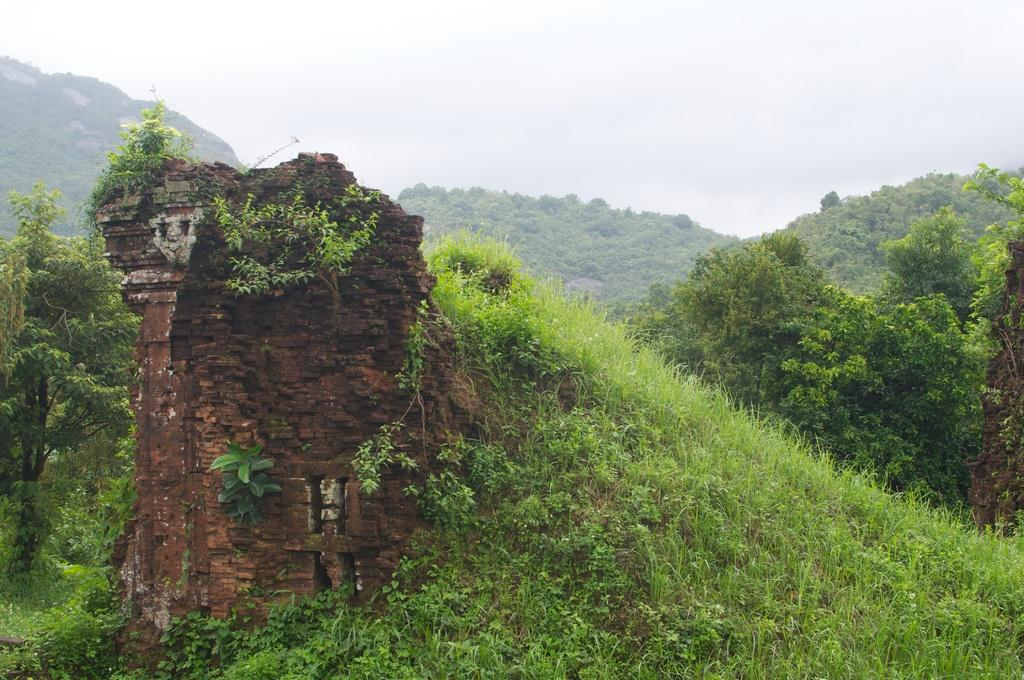What type of vegetation can be seen in the image? There are trees and grass in the image. What type of terrain is visible in the image? There are hills in the image. What is visible in the background of the image? The sky is visible in the image. What can be seen in the sky in the image? Clouds are present in the sky. What type of drink is being served in the image? There is no drink present in the image; it features trees, grass, hills, sky, and clouds. Can you see any stitching on the trees in the image? There is no stitching on the trees in the image; they are natural vegetation. 